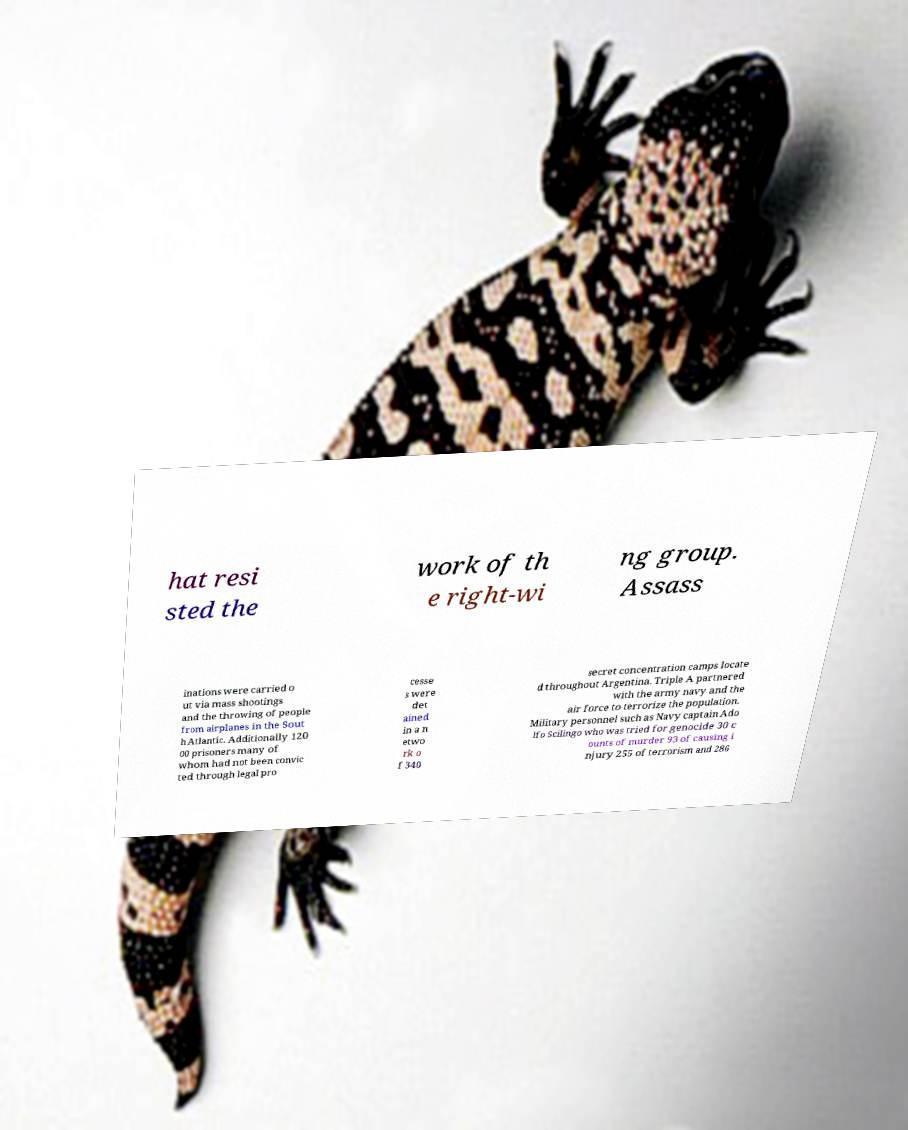Please read and relay the text visible in this image. What does it say? hat resi sted the work of th e right-wi ng group. Assass inations were carried o ut via mass shootings and the throwing of people from airplanes in the Sout h Atlantic. Additionally 120 00 prisoners many of whom had not been convic ted through legal pro cesse s were det ained in a n etwo rk o f 340 secret concentration camps locate d throughout Argentina. Triple A partnered with the army navy and the air force to terrorize the population. Military personnel such as Navy captain Ado lfo Scilingo who was tried for genocide 30 c ounts of murder 93 of causing i njury 255 of terrorism and 286 